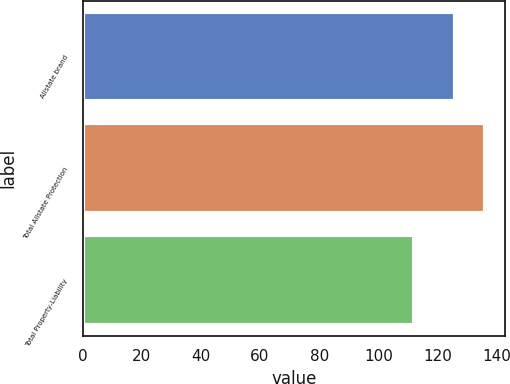Convert chart to OTSL. <chart><loc_0><loc_0><loc_500><loc_500><bar_chart><fcel>Allstate brand<fcel>Total Allstate Protection<fcel>Total Property-Liability<nl><fcel>126<fcel>136<fcel>112<nl></chart> 